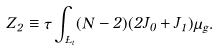Convert formula to latex. <formula><loc_0><loc_0><loc_500><loc_500>Z _ { 2 } \equiv \tau \int _ { \Sigma _ { t } } ( N - 2 ) ( 2 J _ { 0 } + J _ { 1 } ) \mu _ { g } .</formula> 